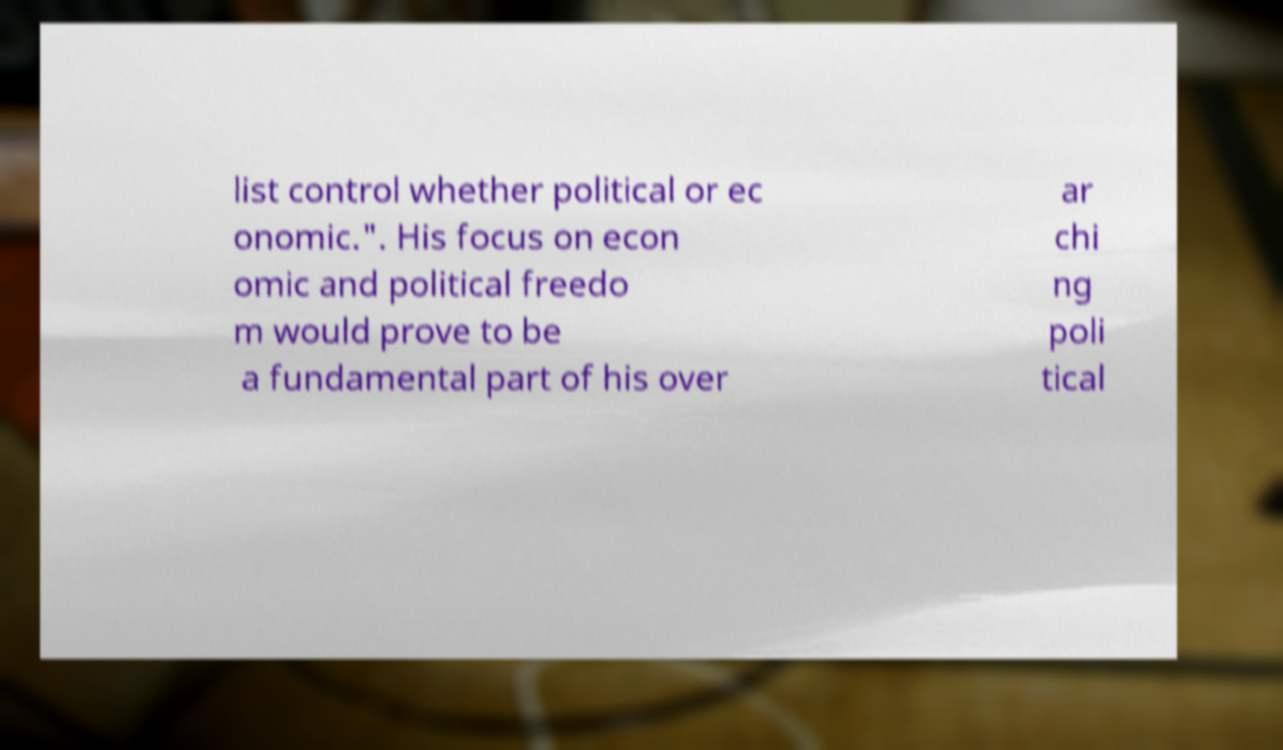Could you assist in decoding the text presented in this image and type it out clearly? list control whether political or ec onomic.". His focus on econ omic and political freedo m would prove to be a fundamental part of his over ar chi ng poli tical 